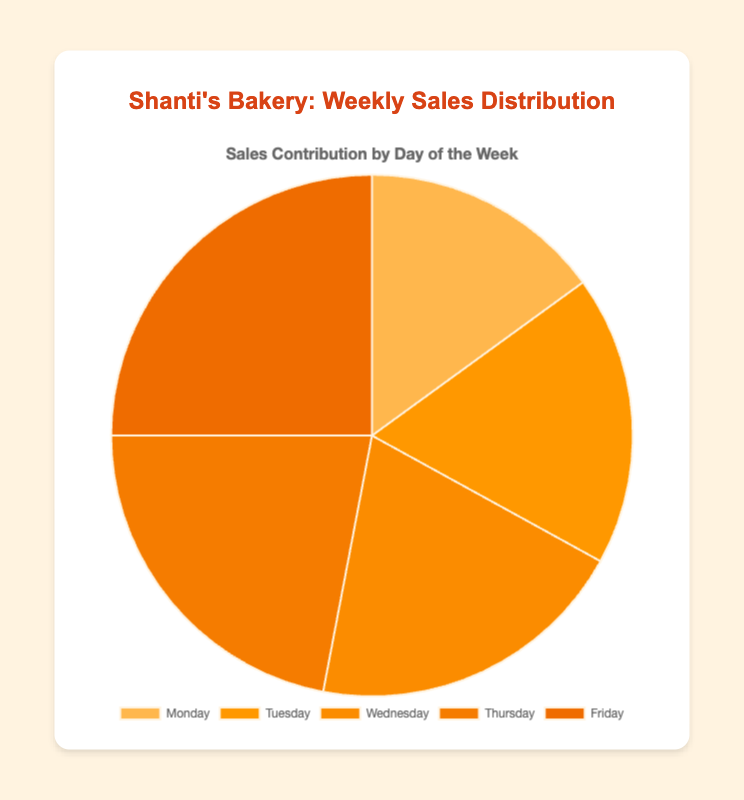What is the total sales percentage for Thursday and Friday? To find the total sales percentage for Thursday and Friday, first, add their individual sales (22 + 25 = 47). Then, find the total sales for the week (15 + 18 + 20 + 22 + 25 = 100). Divide the combined sales of Thursday and Friday by the total sales and multiply by 100 to get the percentage: (47 / 100) * 100 = 47%.
Answer: 47% Which day has the highest sales contribution? Look at the pie chart and identify the largest slice. The largest slice corresponds to Friday, which has 25 sales.
Answer: Friday Is the sales contribution on Wednesday greater than Monday? Compare the sizes of the slices for Wednesday and Monday in the pie chart. Wednesday has 20 sales, which is greater than Monday's 15 sales.
Answer: Yes What is the average sales for the week? To find the average sales, sum the sales for all the days (15 + 18 + 20 + 22 + 25 = 100), then divide by the number of days (5). The average is 100 / 5 = 20.
Answer: 20 What is the difference in sales contribution between Tuesday and Monday? Subtract Monday's sales from Tuesday's sales (18 - 15 = 3).
Answer: 3 What is the combined sales contribution for Monday, Tuesday, and Wednesday? Add the sales for Monday, Tuesday, and Wednesday (15 + 18 + 20 = 53).
Answer: 53 Which day has the smallest sales contribution, and what is its percentage? Identify the smallest slice in the pie chart which corresponds to Monday with 15 sales. The total sales for the week is 100. Therefore, the percentage is (15 / 100) * 100 = 15%.
Answer: Monday, 15% How much more is the sales contribution on Friday compared to that on Tuesday? Subtract Tuesday's sales from Friday's sales (25 - 18 = 7). Friday's sales contribution is 7 more than Tuesday's.
Answer: 7 What percentage of total sales was made from Monday to Wednesday? Add the sales for Monday, Tuesday, and Wednesday (15 + 18 + 20 = 53). Calculate the percentage of total sales: (53 / 100) * 100 = 53%.
Answer: 53% 